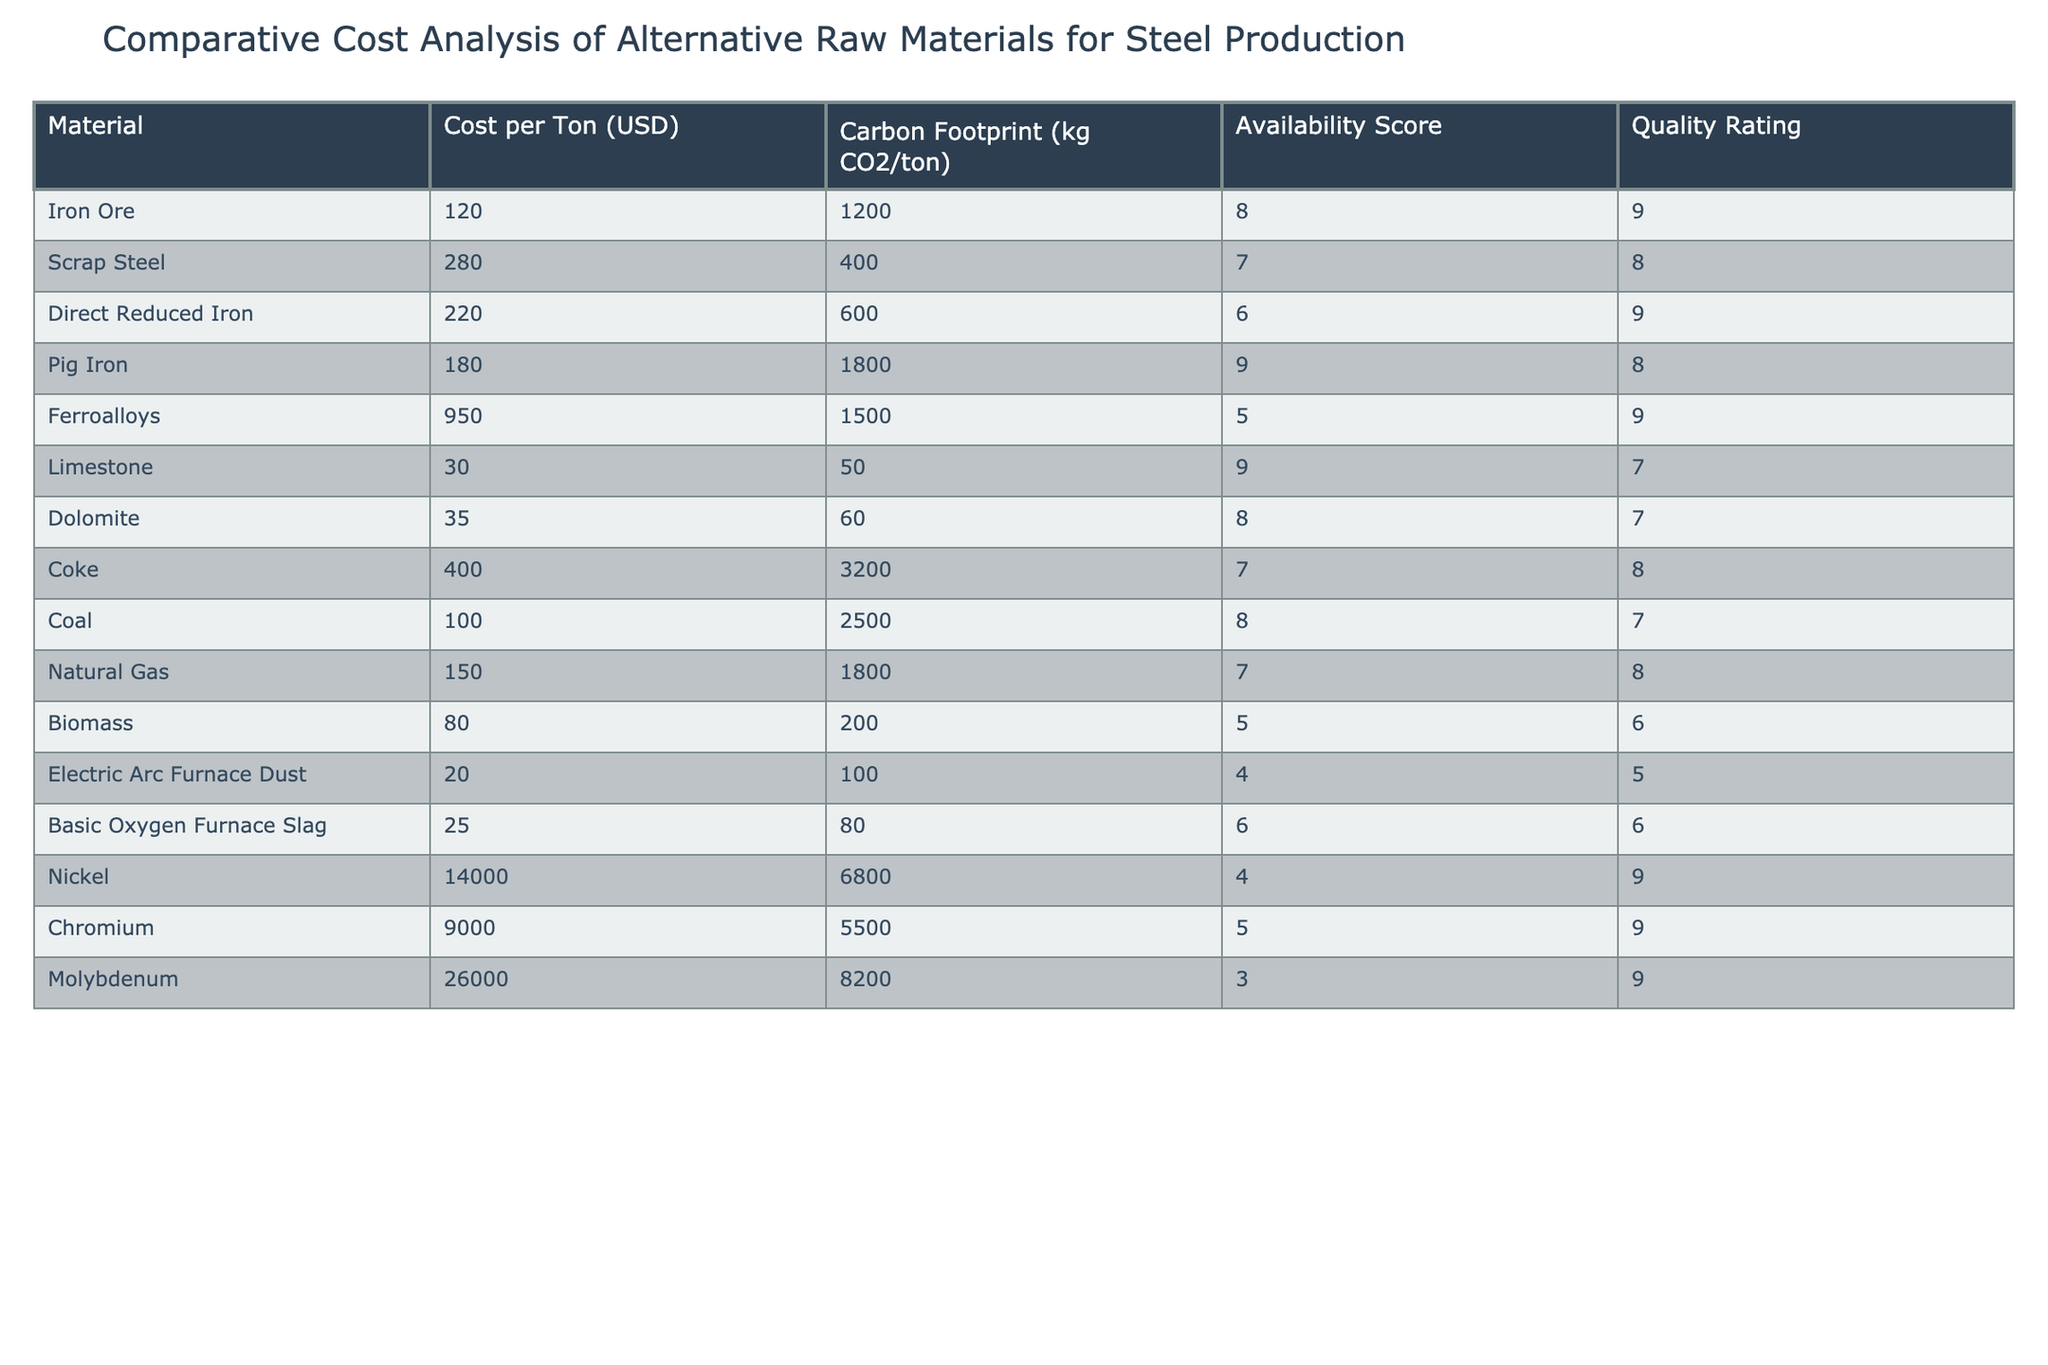What is the cost per ton of Scrap Steel? The cost per ton for Scrap Steel is directly listed in the table under the "Cost per Ton (USD)" column. It shows that the value is 280.
Answer: 280 Which material has the lowest carbon footprint? The carbon footprint values are given in the table, and comparing them reveals that Electric Arc Furnace Dust has the lowest value of 100 kg CO2/ton, less than all other materials listed.
Answer: Electric Arc Furnace Dust What is the availability score of Direct Reduced Iron? The availability score for Direct Reduced Iron can be found in the table under the "Availability Score" column, which shows a score of 6.
Answer: 6 What is the difference in cost per ton between Iron Ore and Pig Iron? To find the difference, subtract the cost per ton of Pig Iron (180) from Iron Ore (120). The calculation is 120 - 180 = -60, which means Iron Ore is cheaper.
Answer: -60 What is the average quality rating of the materials listed? First, sum the quality ratings: 9 + 8 + 9 + 8 + 9 + 7 + 7 + 8 + 8 + 6 + 5 + 6 + 9 + 9 + 9 = 126. Then, count the number of materials, which is 15. Finally, divide the total by the number of materials: 126/15 = 8.4.
Answer: 8.4 Is Coal more cost-effective than Limestone? Compare their costs: Coal is 100 and Limestone is 30. Since 100 is greater than 30, Coal is not more cost-effective than Limestone.
Answer: No Which raw material has the highest quality rating? The highest quality rating from the table can be searched through the "Quality Rating" column. The highest rating is 9, which corresponds to Iron Ore, Direct Reduced Iron, Ferroalloys, Nickel, Chromium, and Molybdenum.
Answer: Iron Ore (and others) What is the total carbon footprint for Limestone and Dolomite combined? The carbon footprints for Limestone and Dolomite are 50 and 60, respectively. To find the total, add those two values: 50 + 60 = 110 kg CO2/ton.
Answer: 110 How does the cost of Biomass compare to the cost of Nickel? The cost per ton for Biomass is 80 and for Nickel, it is 14000. Since 80 is much less than 14000, Biomass is much cheaper than Nickel.
Answer: Yes If we exclude Ferroalloys from the analysis, what is the average cost per ton of the remaining materials? First, sum the costs of all materials except Ferroalloys: 120 + 280 + 220 + 180 + 30 + 35 + 400 + 100 + 150 + 80 + 20 + 25 + 14000 + 9000 + 26000 = 50980. The number of remaining materials is 14. Finally, divide 50980 by 14 to find the average: 50980 / 14 = 3641.43.
Answer: 3641.43 